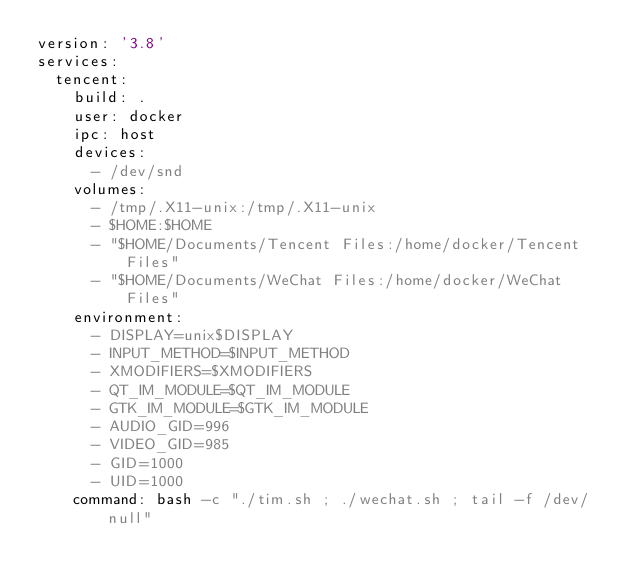Convert code to text. <code><loc_0><loc_0><loc_500><loc_500><_YAML_>version: '3.8'
services:
  tencent:
    build: .
    user: docker
    ipc: host
    devices:
      - /dev/snd
    volumes:
      - /tmp/.X11-unix:/tmp/.X11-unix
      - $HOME:$HOME
      - "$HOME/Documents/Tencent Files:/home/docker/Tencent Files"
      - "$HOME/Documents/WeChat Files:/home/docker/WeChat Files"
    environment:
      - DISPLAY=unix$DISPLAY
      - INPUT_METHOD=$INPUT_METHOD
      - XMODIFIERS=$XMODIFIERS
      - QT_IM_MODULE=$QT_IM_MODULE
      - GTK_IM_MODULE=$GTK_IM_MODULE
      - AUDIO_GID=996
      - VIDEO_GID=985
      - GID=1000
      - UID=1000
    command: bash -c "./tim.sh ; ./wechat.sh ; tail -f /dev/null"
</code> 